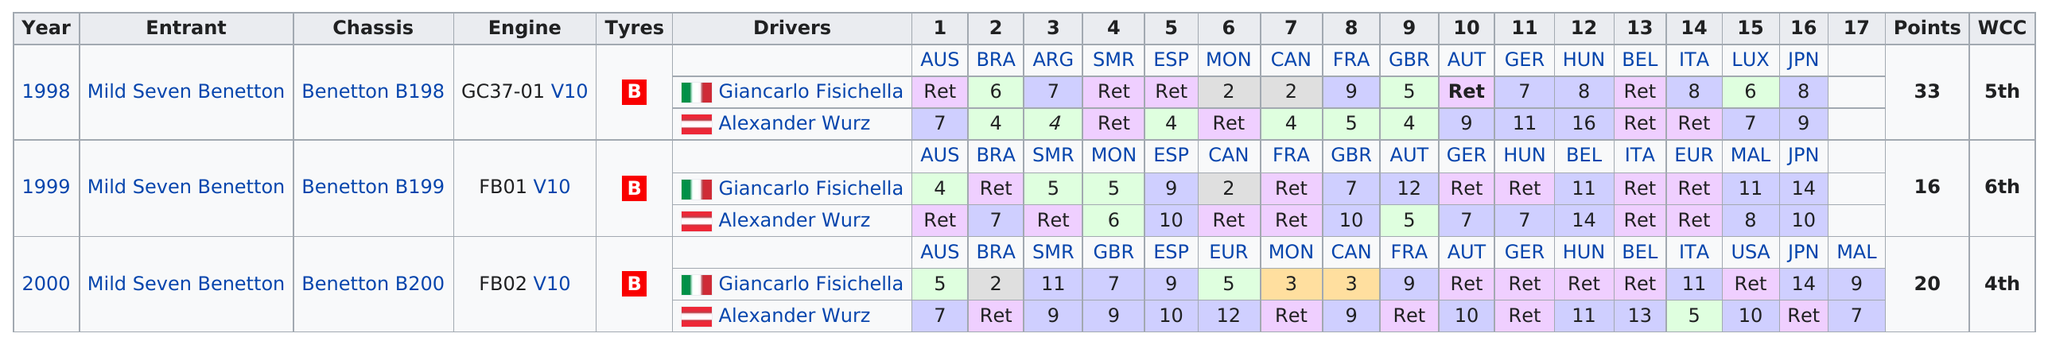Outline some significant characteristics in this image. In 1998, the highest number of points occurred. The Benetton B198 chassis was used from 1998. The engine used after 1999's FB01 V10 was the FB02 V10. 